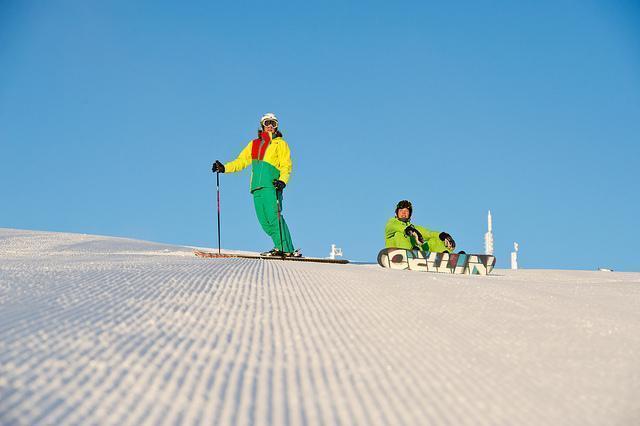What could the condition of the terrain be described as?
Indicate the correct response and explain using: 'Answer: answer
Rationale: rationale.'
Options: Shiny, ridged, groomed, straight. Answer: groomed.
Rationale: The snow on the ground is perfectly tended to for uniformity. 